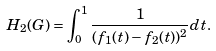Convert formula to latex. <formula><loc_0><loc_0><loc_500><loc_500>H _ { 2 } ( G ) = \int _ { 0 } ^ { 1 } \frac { 1 } { ( f _ { 1 } ( t ) - f _ { 2 } ( t ) ) ^ { 2 } } d t .</formula> 